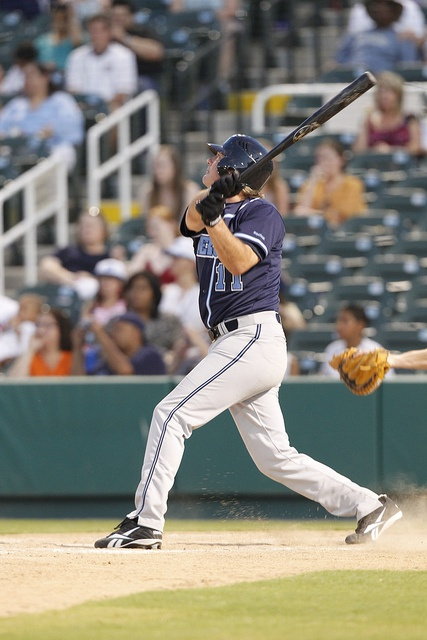Describe the objects in this image and their specific colors. I can see people in black, lightgray, gray, and darkgray tones, people in black, gray, darkgray, tan, and lightgray tones, people in black, darkgray, and gray tones, people in black and gray tones, and people in black, gray, and darkgray tones in this image. 